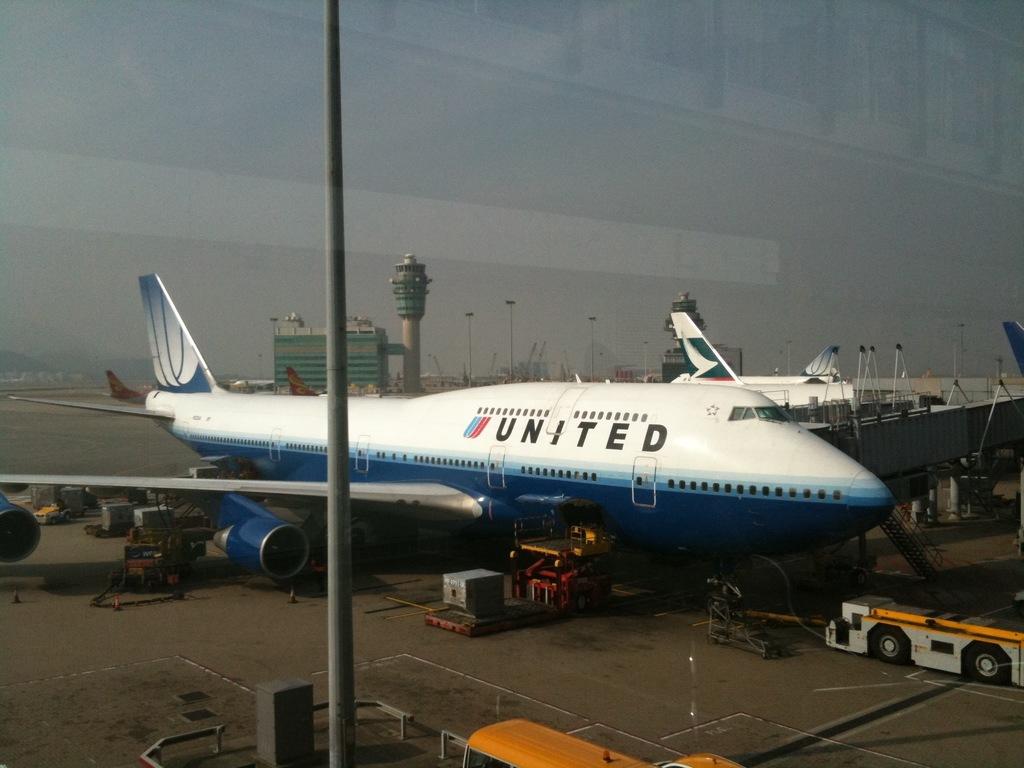What airline does the plane belong to?
Make the answer very short. United. 